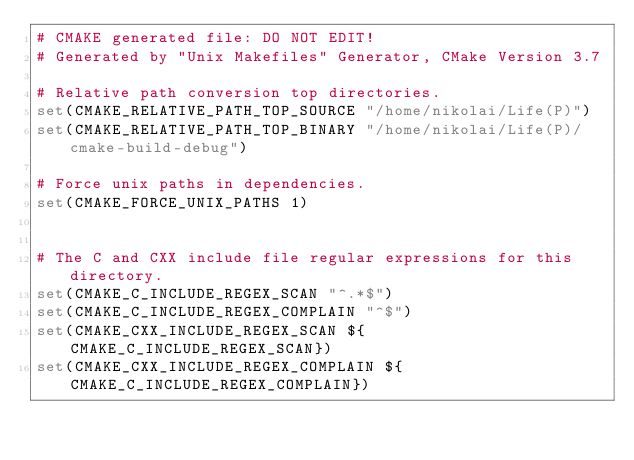<code> <loc_0><loc_0><loc_500><loc_500><_CMake_># CMAKE generated file: DO NOT EDIT!
# Generated by "Unix Makefiles" Generator, CMake Version 3.7

# Relative path conversion top directories.
set(CMAKE_RELATIVE_PATH_TOP_SOURCE "/home/nikolai/Life(P)")
set(CMAKE_RELATIVE_PATH_TOP_BINARY "/home/nikolai/Life(P)/cmake-build-debug")

# Force unix paths in dependencies.
set(CMAKE_FORCE_UNIX_PATHS 1)


# The C and CXX include file regular expressions for this directory.
set(CMAKE_C_INCLUDE_REGEX_SCAN "^.*$")
set(CMAKE_C_INCLUDE_REGEX_COMPLAIN "^$")
set(CMAKE_CXX_INCLUDE_REGEX_SCAN ${CMAKE_C_INCLUDE_REGEX_SCAN})
set(CMAKE_CXX_INCLUDE_REGEX_COMPLAIN ${CMAKE_C_INCLUDE_REGEX_COMPLAIN})
</code> 